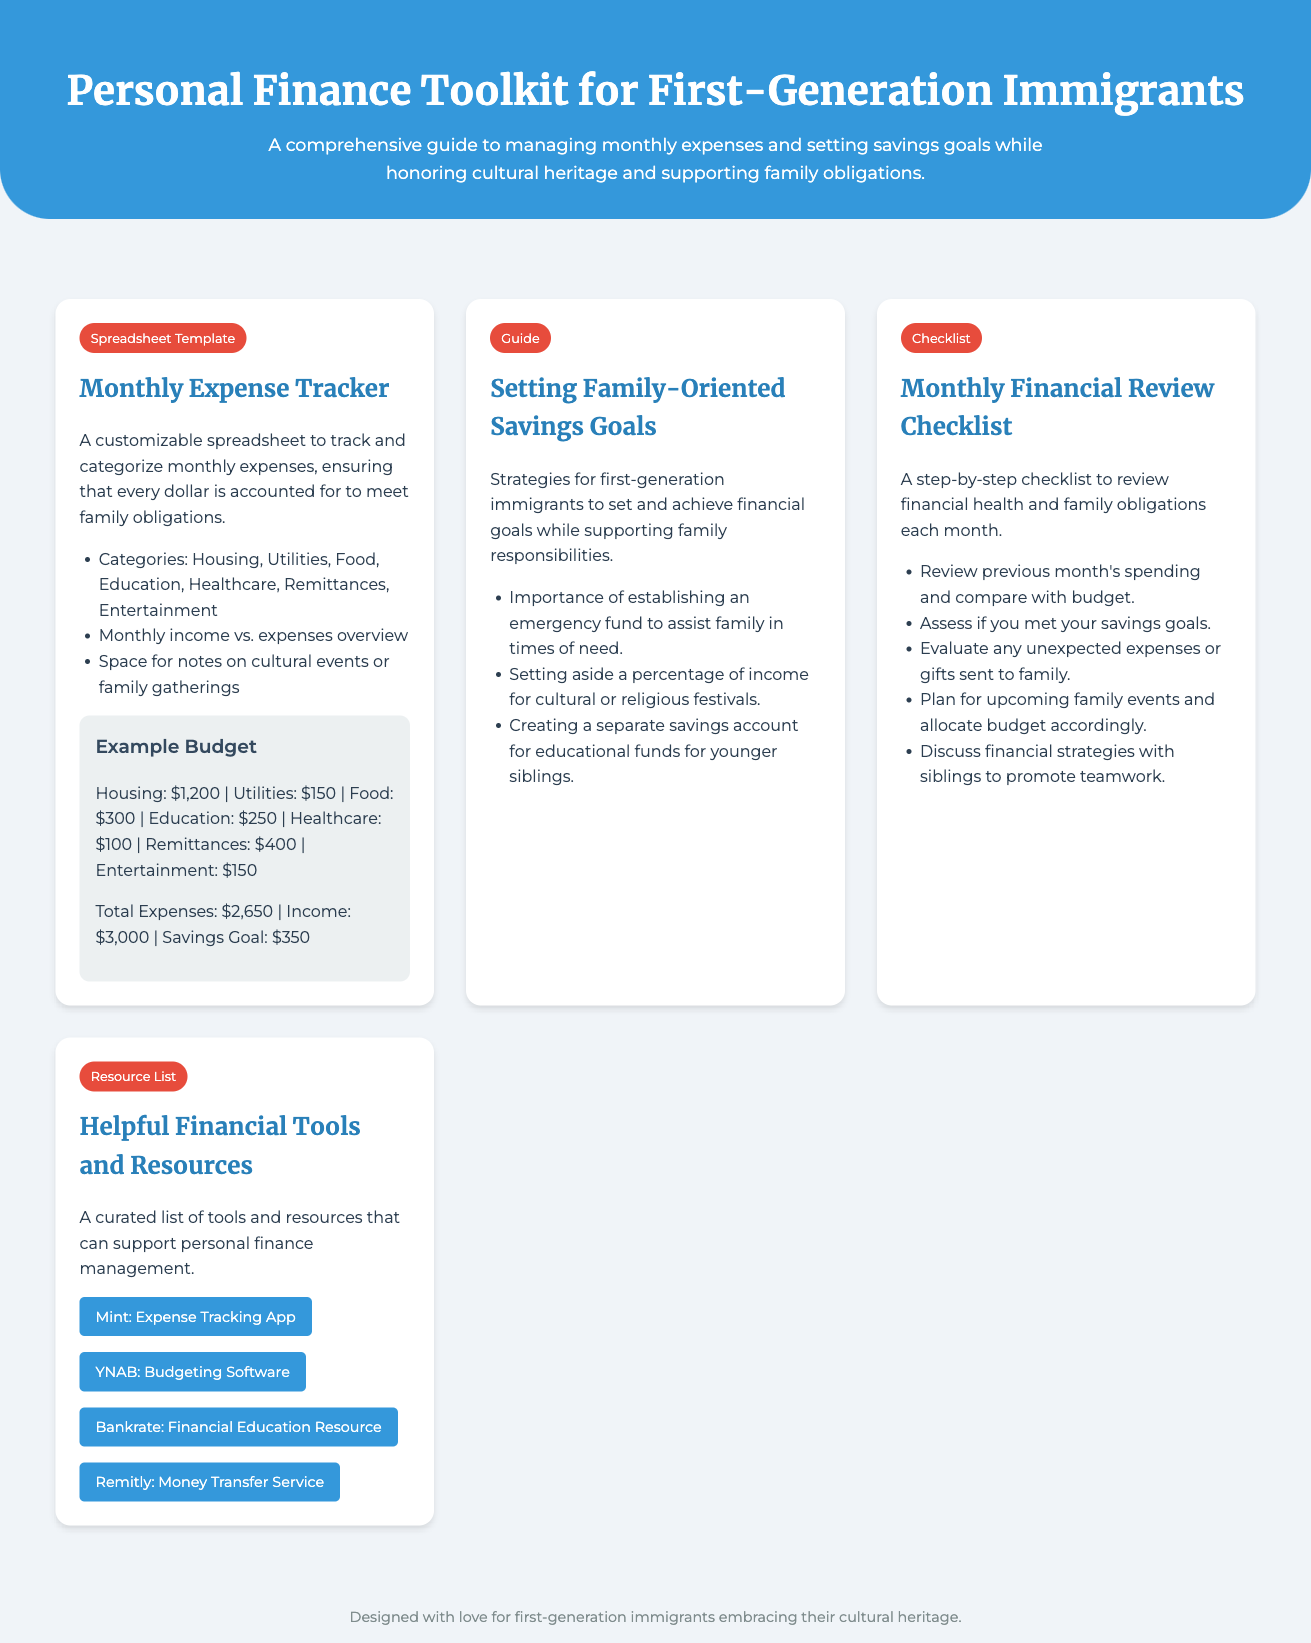What is the title of the document? The title of the document is presented prominently in the header section.
Answer: Personal Finance Toolkit for First-Generation Immigrants What categories are included in the Monthly Expense Tracker? The categories are listed in the description of the Monthly Expense Tracker material.
Answer: Housing, Utilities, Food, Education, Healthcare, Remittances, Entertainment What is the savings goal mentioned in the example budget? The savings goal is detailed in the example budget section provided in the Monthly Expense Tracker.
Answer: $350 What should be set aside for cultural or religious festivals? This is stated in the strategies for setting family-oriented savings goals.
Answer: A percentage of income How many resources are mentioned in the Helpful Financial Tools and Resources? The number of resources is determined by counting the items listed in the resources section.
Answer: Four What is one item listed as a helpful financial tool? The helpful tools and resources section provides a curated list of tools.
Answer: Mint: Expense Tracking App What is the purpose of the Monthly Financial Review Checklist? The checklist's purpose is described in the intro of the checklist material.
Answer: To review financial health and family obligations What should you do to promote teamwork according to the checklist? This suggests a specific action related to teamwork mentioned in the Monthly Financial Review Checklist.
Answer: Discuss financial strategies with siblings 